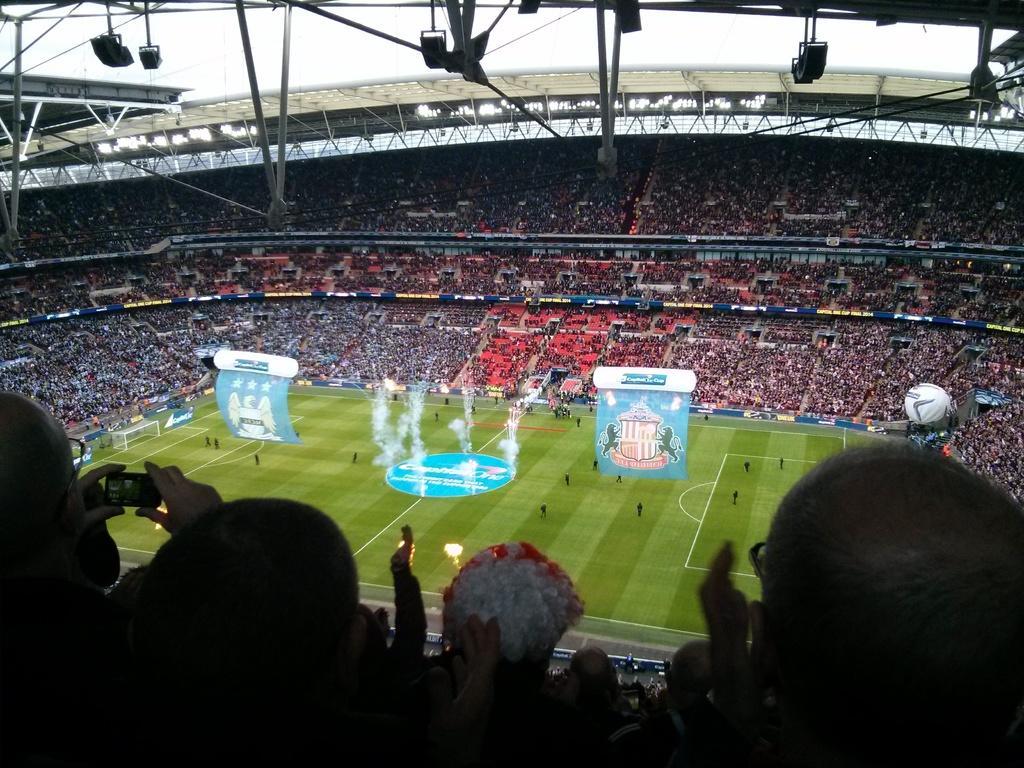Please provide a concise description of this image. In this picture we can see a stadium, there are some people standing on the ground, we can see smoke in the middle, we can see people in the front and in the background, on the right side there is a balloon, we can see metal rods and the sky at the top of the picture, on the left side there is a goal post, there are hoardings in the background. 